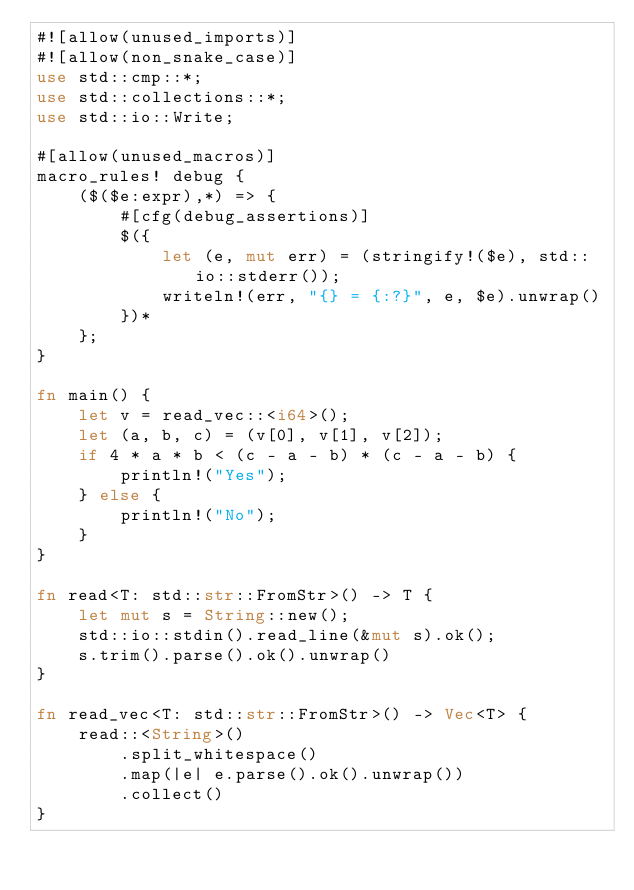<code> <loc_0><loc_0><loc_500><loc_500><_Rust_>#![allow(unused_imports)]
#![allow(non_snake_case)]
use std::cmp::*;
use std::collections::*;
use std::io::Write;

#[allow(unused_macros)]
macro_rules! debug {
    ($($e:expr),*) => {
        #[cfg(debug_assertions)]
        $({
            let (e, mut err) = (stringify!($e), std::io::stderr());
            writeln!(err, "{} = {:?}", e, $e).unwrap()
        })*
    };
}

fn main() {
    let v = read_vec::<i64>();
    let (a, b, c) = (v[0], v[1], v[2]);
    if 4 * a * b < (c - a - b) * (c - a - b) {
        println!("Yes");
    } else {
        println!("No");
    }
}

fn read<T: std::str::FromStr>() -> T {
    let mut s = String::new();
    std::io::stdin().read_line(&mut s).ok();
    s.trim().parse().ok().unwrap()
}

fn read_vec<T: std::str::FromStr>() -> Vec<T> {
    read::<String>()
        .split_whitespace()
        .map(|e| e.parse().ok().unwrap())
        .collect()
}
</code> 